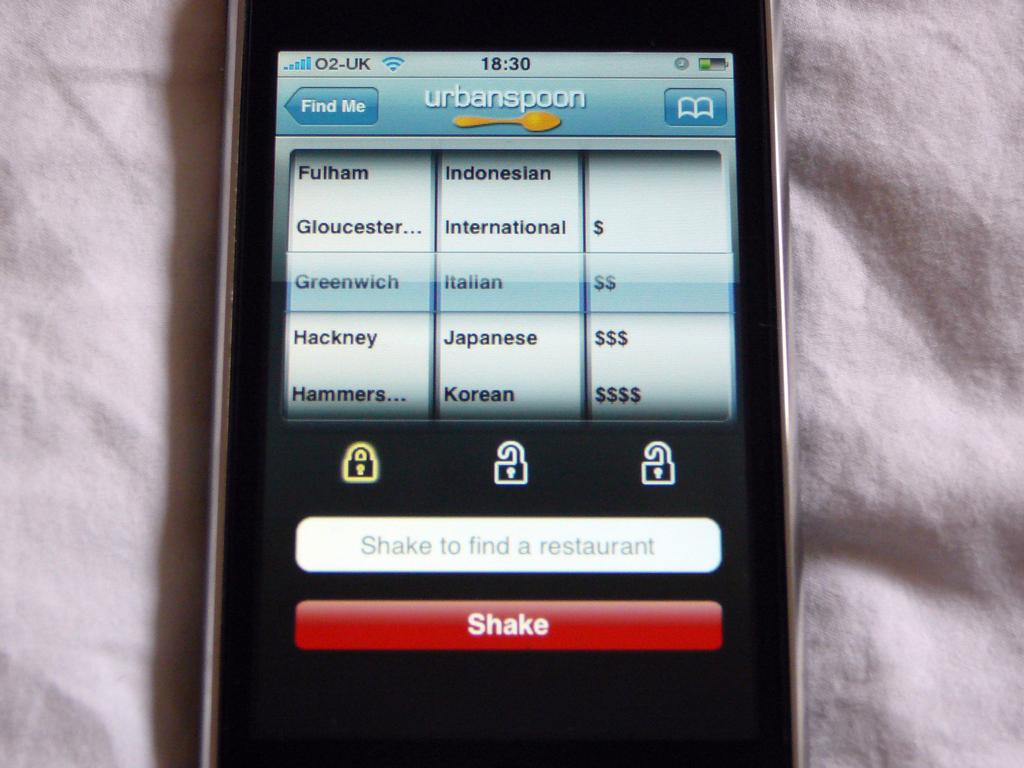<image>
Give a short and clear explanation of the subsequent image. a shake button at the bottom of the screen 